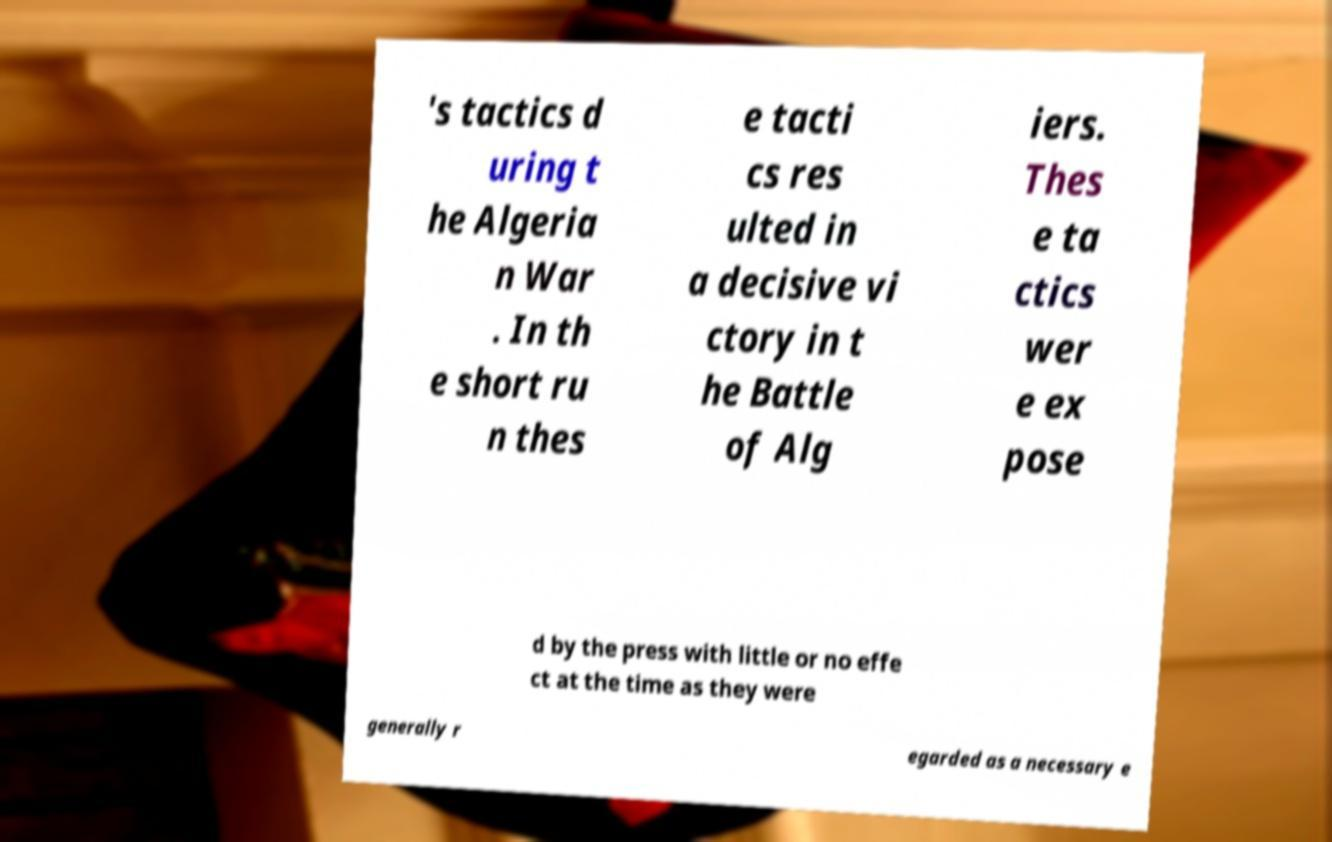Can you read and provide the text displayed in the image?This photo seems to have some interesting text. Can you extract and type it out for me? 's tactics d uring t he Algeria n War . In th e short ru n thes e tacti cs res ulted in a decisive vi ctory in t he Battle of Alg iers. Thes e ta ctics wer e ex pose d by the press with little or no effe ct at the time as they were generally r egarded as a necessary e 